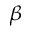<formula> <loc_0><loc_0><loc_500><loc_500>_ { \beta }</formula> 